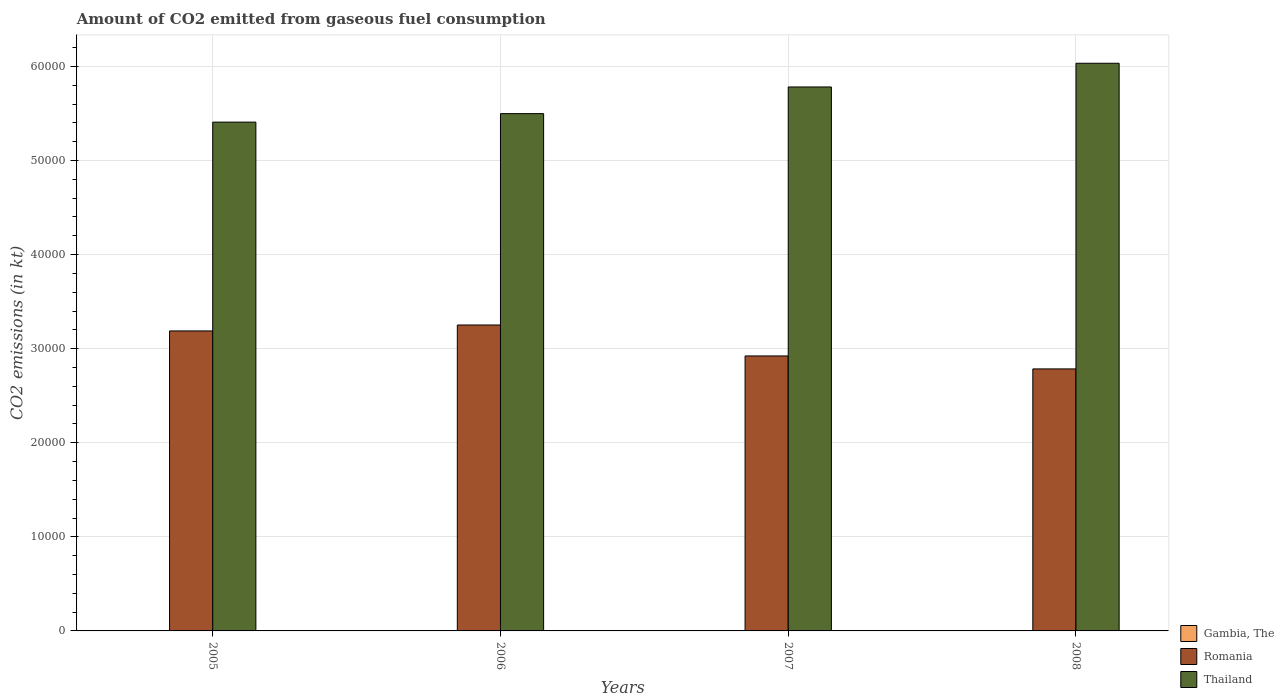Are the number of bars per tick equal to the number of legend labels?
Provide a short and direct response. Yes. How many bars are there on the 2nd tick from the left?
Ensure brevity in your answer.  3. How many bars are there on the 2nd tick from the right?
Your response must be concise. 3. What is the label of the 3rd group of bars from the left?
Give a very brief answer. 2007. In how many cases, is the number of bars for a given year not equal to the number of legend labels?
Provide a short and direct response. 0. What is the amount of CO2 emitted in Gambia, The in 2006?
Your answer should be compact. 3.67. Across all years, what is the maximum amount of CO2 emitted in Romania?
Your answer should be very brief. 3.25e+04. Across all years, what is the minimum amount of CO2 emitted in Thailand?
Provide a succinct answer. 5.41e+04. In which year was the amount of CO2 emitted in Romania maximum?
Provide a succinct answer. 2006. In which year was the amount of CO2 emitted in Thailand minimum?
Make the answer very short. 2005. What is the total amount of CO2 emitted in Romania in the graph?
Offer a terse response. 1.21e+05. What is the difference between the amount of CO2 emitted in Gambia, The in 2005 and that in 2006?
Your response must be concise. 0. What is the difference between the amount of CO2 emitted in Romania in 2008 and the amount of CO2 emitted in Gambia, The in 2006?
Provide a succinct answer. 2.78e+04. What is the average amount of CO2 emitted in Thailand per year?
Offer a terse response. 5.68e+04. In the year 2005, what is the difference between the amount of CO2 emitted in Romania and amount of CO2 emitted in Gambia, The?
Give a very brief answer. 3.19e+04. In how many years, is the amount of CO2 emitted in Thailand greater than 38000 kt?
Your answer should be compact. 4. What is the ratio of the amount of CO2 emitted in Romania in 2007 to that in 2008?
Your answer should be compact. 1.05. Is the amount of CO2 emitted in Thailand in 2005 less than that in 2006?
Your response must be concise. Yes. Is the difference between the amount of CO2 emitted in Romania in 2006 and 2008 greater than the difference between the amount of CO2 emitted in Gambia, The in 2006 and 2008?
Give a very brief answer. Yes. What is the difference between the highest and the second highest amount of CO2 emitted in Gambia, The?
Provide a succinct answer. 0. What is the difference between the highest and the lowest amount of CO2 emitted in Gambia, The?
Provide a succinct answer. 0. What does the 3rd bar from the left in 2006 represents?
Offer a terse response. Thailand. What does the 2nd bar from the right in 2008 represents?
Make the answer very short. Romania. How many bars are there?
Your answer should be very brief. 12. Are all the bars in the graph horizontal?
Provide a short and direct response. No. Does the graph contain any zero values?
Your response must be concise. No. Does the graph contain grids?
Offer a very short reply. Yes. What is the title of the graph?
Make the answer very short. Amount of CO2 emitted from gaseous fuel consumption. Does "Lesotho" appear as one of the legend labels in the graph?
Your answer should be very brief. No. What is the label or title of the Y-axis?
Ensure brevity in your answer.  CO2 emissions (in kt). What is the CO2 emissions (in kt) in Gambia, The in 2005?
Your answer should be compact. 3.67. What is the CO2 emissions (in kt) of Romania in 2005?
Your answer should be compact. 3.19e+04. What is the CO2 emissions (in kt) of Thailand in 2005?
Ensure brevity in your answer.  5.41e+04. What is the CO2 emissions (in kt) in Gambia, The in 2006?
Your response must be concise. 3.67. What is the CO2 emissions (in kt) in Romania in 2006?
Offer a very short reply. 3.25e+04. What is the CO2 emissions (in kt) of Thailand in 2006?
Offer a terse response. 5.50e+04. What is the CO2 emissions (in kt) of Gambia, The in 2007?
Offer a terse response. 3.67. What is the CO2 emissions (in kt) of Romania in 2007?
Give a very brief answer. 2.92e+04. What is the CO2 emissions (in kt) in Thailand in 2007?
Ensure brevity in your answer.  5.78e+04. What is the CO2 emissions (in kt) of Gambia, The in 2008?
Offer a very short reply. 3.67. What is the CO2 emissions (in kt) in Romania in 2008?
Your response must be concise. 2.79e+04. What is the CO2 emissions (in kt) of Thailand in 2008?
Provide a short and direct response. 6.03e+04. Across all years, what is the maximum CO2 emissions (in kt) of Gambia, The?
Make the answer very short. 3.67. Across all years, what is the maximum CO2 emissions (in kt) of Romania?
Ensure brevity in your answer.  3.25e+04. Across all years, what is the maximum CO2 emissions (in kt) of Thailand?
Provide a succinct answer. 6.03e+04. Across all years, what is the minimum CO2 emissions (in kt) of Gambia, The?
Make the answer very short. 3.67. Across all years, what is the minimum CO2 emissions (in kt) of Romania?
Offer a terse response. 2.79e+04. Across all years, what is the minimum CO2 emissions (in kt) in Thailand?
Your answer should be compact. 5.41e+04. What is the total CO2 emissions (in kt) in Gambia, The in the graph?
Give a very brief answer. 14.67. What is the total CO2 emissions (in kt) of Romania in the graph?
Ensure brevity in your answer.  1.21e+05. What is the total CO2 emissions (in kt) of Thailand in the graph?
Make the answer very short. 2.27e+05. What is the difference between the CO2 emissions (in kt) of Romania in 2005 and that in 2006?
Ensure brevity in your answer.  -630.72. What is the difference between the CO2 emissions (in kt) in Thailand in 2005 and that in 2006?
Provide a short and direct response. -902.08. What is the difference between the CO2 emissions (in kt) of Gambia, The in 2005 and that in 2007?
Offer a terse response. 0. What is the difference between the CO2 emissions (in kt) of Romania in 2005 and that in 2007?
Your answer should be compact. 2658.57. What is the difference between the CO2 emissions (in kt) of Thailand in 2005 and that in 2007?
Your answer should be very brief. -3736.67. What is the difference between the CO2 emissions (in kt) in Gambia, The in 2005 and that in 2008?
Offer a terse response. 0. What is the difference between the CO2 emissions (in kt) in Romania in 2005 and that in 2008?
Make the answer very short. 4037.37. What is the difference between the CO2 emissions (in kt) in Thailand in 2005 and that in 2008?
Provide a short and direct response. -6255.9. What is the difference between the CO2 emissions (in kt) in Romania in 2006 and that in 2007?
Provide a succinct answer. 3289.3. What is the difference between the CO2 emissions (in kt) of Thailand in 2006 and that in 2007?
Keep it short and to the point. -2834.59. What is the difference between the CO2 emissions (in kt) in Romania in 2006 and that in 2008?
Your response must be concise. 4668.09. What is the difference between the CO2 emissions (in kt) in Thailand in 2006 and that in 2008?
Your answer should be very brief. -5353.82. What is the difference between the CO2 emissions (in kt) in Gambia, The in 2007 and that in 2008?
Your answer should be compact. 0. What is the difference between the CO2 emissions (in kt) of Romania in 2007 and that in 2008?
Keep it short and to the point. 1378.79. What is the difference between the CO2 emissions (in kt) of Thailand in 2007 and that in 2008?
Make the answer very short. -2519.23. What is the difference between the CO2 emissions (in kt) of Gambia, The in 2005 and the CO2 emissions (in kt) of Romania in 2006?
Keep it short and to the point. -3.25e+04. What is the difference between the CO2 emissions (in kt) of Gambia, The in 2005 and the CO2 emissions (in kt) of Thailand in 2006?
Your answer should be compact. -5.50e+04. What is the difference between the CO2 emissions (in kt) of Romania in 2005 and the CO2 emissions (in kt) of Thailand in 2006?
Your answer should be compact. -2.31e+04. What is the difference between the CO2 emissions (in kt) of Gambia, The in 2005 and the CO2 emissions (in kt) of Romania in 2007?
Keep it short and to the point. -2.92e+04. What is the difference between the CO2 emissions (in kt) in Gambia, The in 2005 and the CO2 emissions (in kt) in Thailand in 2007?
Ensure brevity in your answer.  -5.78e+04. What is the difference between the CO2 emissions (in kt) of Romania in 2005 and the CO2 emissions (in kt) of Thailand in 2007?
Offer a terse response. -2.59e+04. What is the difference between the CO2 emissions (in kt) in Gambia, The in 2005 and the CO2 emissions (in kt) in Romania in 2008?
Your response must be concise. -2.78e+04. What is the difference between the CO2 emissions (in kt) in Gambia, The in 2005 and the CO2 emissions (in kt) in Thailand in 2008?
Ensure brevity in your answer.  -6.03e+04. What is the difference between the CO2 emissions (in kt) in Romania in 2005 and the CO2 emissions (in kt) in Thailand in 2008?
Your response must be concise. -2.85e+04. What is the difference between the CO2 emissions (in kt) in Gambia, The in 2006 and the CO2 emissions (in kt) in Romania in 2007?
Give a very brief answer. -2.92e+04. What is the difference between the CO2 emissions (in kt) of Gambia, The in 2006 and the CO2 emissions (in kt) of Thailand in 2007?
Your answer should be compact. -5.78e+04. What is the difference between the CO2 emissions (in kt) in Romania in 2006 and the CO2 emissions (in kt) in Thailand in 2007?
Ensure brevity in your answer.  -2.53e+04. What is the difference between the CO2 emissions (in kt) in Gambia, The in 2006 and the CO2 emissions (in kt) in Romania in 2008?
Offer a very short reply. -2.78e+04. What is the difference between the CO2 emissions (in kt) of Gambia, The in 2006 and the CO2 emissions (in kt) of Thailand in 2008?
Ensure brevity in your answer.  -6.03e+04. What is the difference between the CO2 emissions (in kt) of Romania in 2006 and the CO2 emissions (in kt) of Thailand in 2008?
Make the answer very short. -2.78e+04. What is the difference between the CO2 emissions (in kt) in Gambia, The in 2007 and the CO2 emissions (in kt) in Romania in 2008?
Provide a short and direct response. -2.78e+04. What is the difference between the CO2 emissions (in kt) in Gambia, The in 2007 and the CO2 emissions (in kt) in Thailand in 2008?
Make the answer very short. -6.03e+04. What is the difference between the CO2 emissions (in kt) of Romania in 2007 and the CO2 emissions (in kt) of Thailand in 2008?
Offer a very short reply. -3.11e+04. What is the average CO2 emissions (in kt) of Gambia, The per year?
Offer a terse response. 3.67. What is the average CO2 emissions (in kt) of Romania per year?
Give a very brief answer. 3.04e+04. What is the average CO2 emissions (in kt) in Thailand per year?
Your answer should be compact. 5.68e+04. In the year 2005, what is the difference between the CO2 emissions (in kt) of Gambia, The and CO2 emissions (in kt) of Romania?
Ensure brevity in your answer.  -3.19e+04. In the year 2005, what is the difference between the CO2 emissions (in kt) of Gambia, The and CO2 emissions (in kt) of Thailand?
Give a very brief answer. -5.41e+04. In the year 2005, what is the difference between the CO2 emissions (in kt) of Romania and CO2 emissions (in kt) of Thailand?
Ensure brevity in your answer.  -2.22e+04. In the year 2006, what is the difference between the CO2 emissions (in kt) in Gambia, The and CO2 emissions (in kt) in Romania?
Offer a very short reply. -3.25e+04. In the year 2006, what is the difference between the CO2 emissions (in kt) of Gambia, The and CO2 emissions (in kt) of Thailand?
Ensure brevity in your answer.  -5.50e+04. In the year 2006, what is the difference between the CO2 emissions (in kt) in Romania and CO2 emissions (in kt) in Thailand?
Your response must be concise. -2.25e+04. In the year 2007, what is the difference between the CO2 emissions (in kt) in Gambia, The and CO2 emissions (in kt) in Romania?
Offer a very short reply. -2.92e+04. In the year 2007, what is the difference between the CO2 emissions (in kt) in Gambia, The and CO2 emissions (in kt) in Thailand?
Ensure brevity in your answer.  -5.78e+04. In the year 2007, what is the difference between the CO2 emissions (in kt) in Romania and CO2 emissions (in kt) in Thailand?
Give a very brief answer. -2.86e+04. In the year 2008, what is the difference between the CO2 emissions (in kt) in Gambia, The and CO2 emissions (in kt) in Romania?
Ensure brevity in your answer.  -2.78e+04. In the year 2008, what is the difference between the CO2 emissions (in kt) in Gambia, The and CO2 emissions (in kt) in Thailand?
Offer a terse response. -6.03e+04. In the year 2008, what is the difference between the CO2 emissions (in kt) of Romania and CO2 emissions (in kt) of Thailand?
Your answer should be compact. -3.25e+04. What is the ratio of the CO2 emissions (in kt) of Gambia, The in 2005 to that in 2006?
Keep it short and to the point. 1. What is the ratio of the CO2 emissions (in kt) of Romania in 2005 to that in 2006?
Give a very brief answer. 0.98. What is the ratio of the CO2 emissions (in kt) in Thailand in 2005 to that in 2006?
Ensure brevity in your answer.  0.98. What is the ratio of the CO2 emissions (in kt) in Gambia, The in 2005 to that in 2007?
Ensure brevity in your answer.  1. What is the ratio of the CO2 emissions (in kt) of Romania in 2005 to that in 2007?
Provide a short and direct response. 1.09. What is the ratio of the CO2 emissions (in kt) in Thailand in 2005 to that in 2007?
Your response must be concise. 0.94. What is the ratio of the CO2 emissions (in kt) in Romania in 2005 to that in 2008?
Offer a terse response. 1.15. What is the ratio of the CO2 emissions (in kt) in Thailand in 2005 to that in 2008?
Keep it short and to the point. 0.9. What is the ratio of the CO2 emissions (in kt) in Romania in 2006 to that in 2007?
Your answer should be very brief. 1.11. What is the ratio of the CO2 emissions (in kt) of Thailand in 2006 to that in 2007?
Your response must be concise. 0.95. What is the ratio of the CO2 emissions (in kt) of Romania in 2006 to that in 2008?
Your response must be concise. 1.17. What is the ratio of the CO2 emissions (in kt) in Thailand in 2006 to that in 2008?
Your answer should be compact. 0.91. What is the ratio of the CO2 emissions (in kt) of Romania in 2007 to that in 2008?
Your answer should be compact. 1.05. What is the ratio of the CO2 emissions (in kt) of Thailand in 2007 to that in 2008?
Keep it short and to the point. 0.96. What is the difference between the highest and the second highest CO2 emissions (in kt) in Gambia, The?
Provide a short and direct response. 0. What is the difference between the highest and the second highest CO2 emissions (in kt) of Romania?
Keep it short and to the point. 630.72. What is the difference between the highest and the second highest CO2 emissions (in kt) in Thailand?
Ensure brevity in your answer.  2519.23. What is the difference between the highest and the lowest CO2 emissions (in kt) of Romania?
Provide a short and direct response. 4668.09. What is the difference between the highest and the lowest CO2 emissions (in kt) of Thailand?
Your response must be concise. 6255.9. 